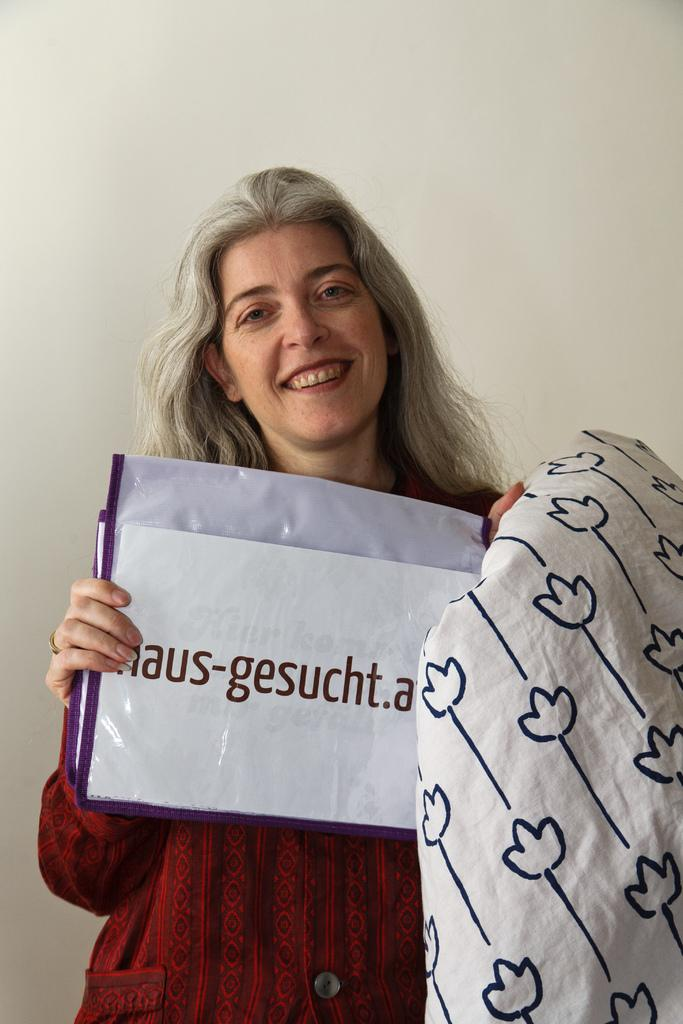Who is present in the image? There is a lady in the image. What is the lady holding in the image? The lady is holding a paper with something written. What else can be seen in the image besides the lady and the paper? There is a cloth in the image. What is visible in the background of the image? There is a wall in the background of the image. What type of cork can be seen in the image? There is no cork present in the image. What kind of prose is the lady reading from the paper? The lady is holding a paper with something written, but there is no indication of the content being prose or any specific type of writing. 